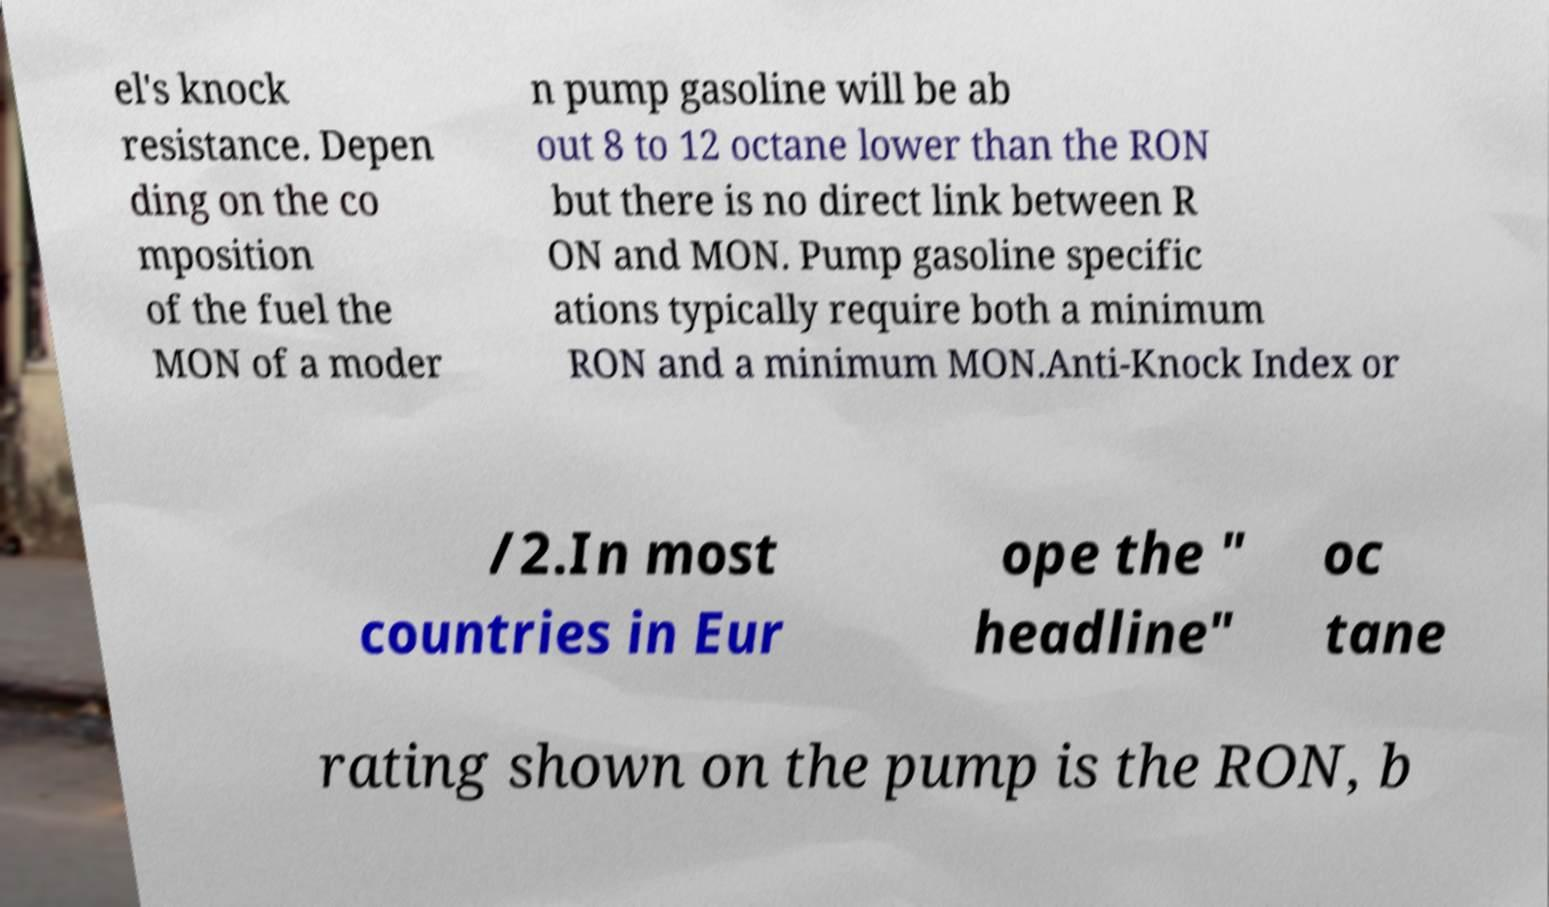Please identify and transcribe the text found in this image. el's knock resistance. Depen ding on the co mposition of the fuel the MON of a moder n pump gasoline will be ab out 8 to 12 octane lower than the RON but there is no direct link between R ON and MON. Pump gasoline specific ations typically require both a minimum RON and a minimum MON.Anti-Knock Index or /2.In most countries in Eur ope the " headline" oc tane rating shown on the pump is the RON, b 